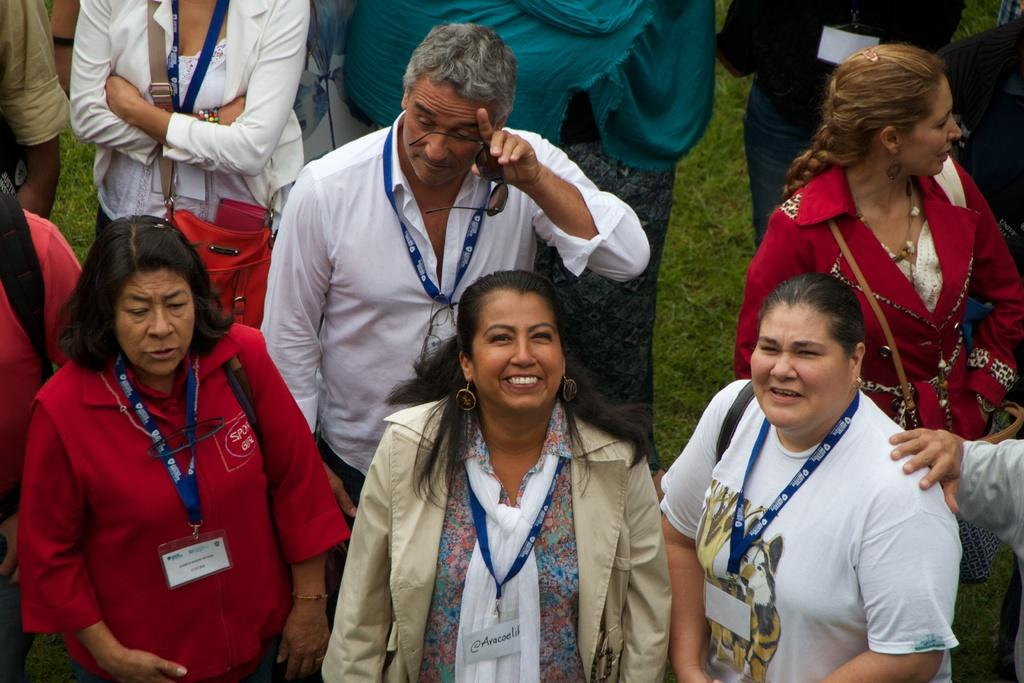What is the main subject of the image? The main subject of the image is a group of people. Where are the people located in the image? The people are standing together in the grass. What can be observed about the people's attire in the image? The people are wearing blue color tags. What type of canvas can be seen in the background of the image? There is no canvas present in the image. Are there any cobwebs visible on the people in the image? There are no cobwebs visible on the people in the image. 